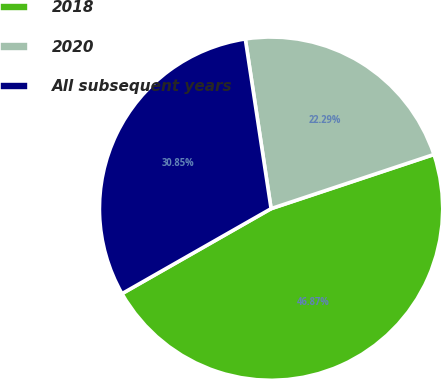Convert chart to OTSL. <chart><loc_0><loc_0><loc_500><loc_500><pie_chart><fcel>2018<fcel>2020<fcel>All subsequent years<nl><fcel>46.87%<fcel>22.29%<fcel>30.85%<nl></chart> 